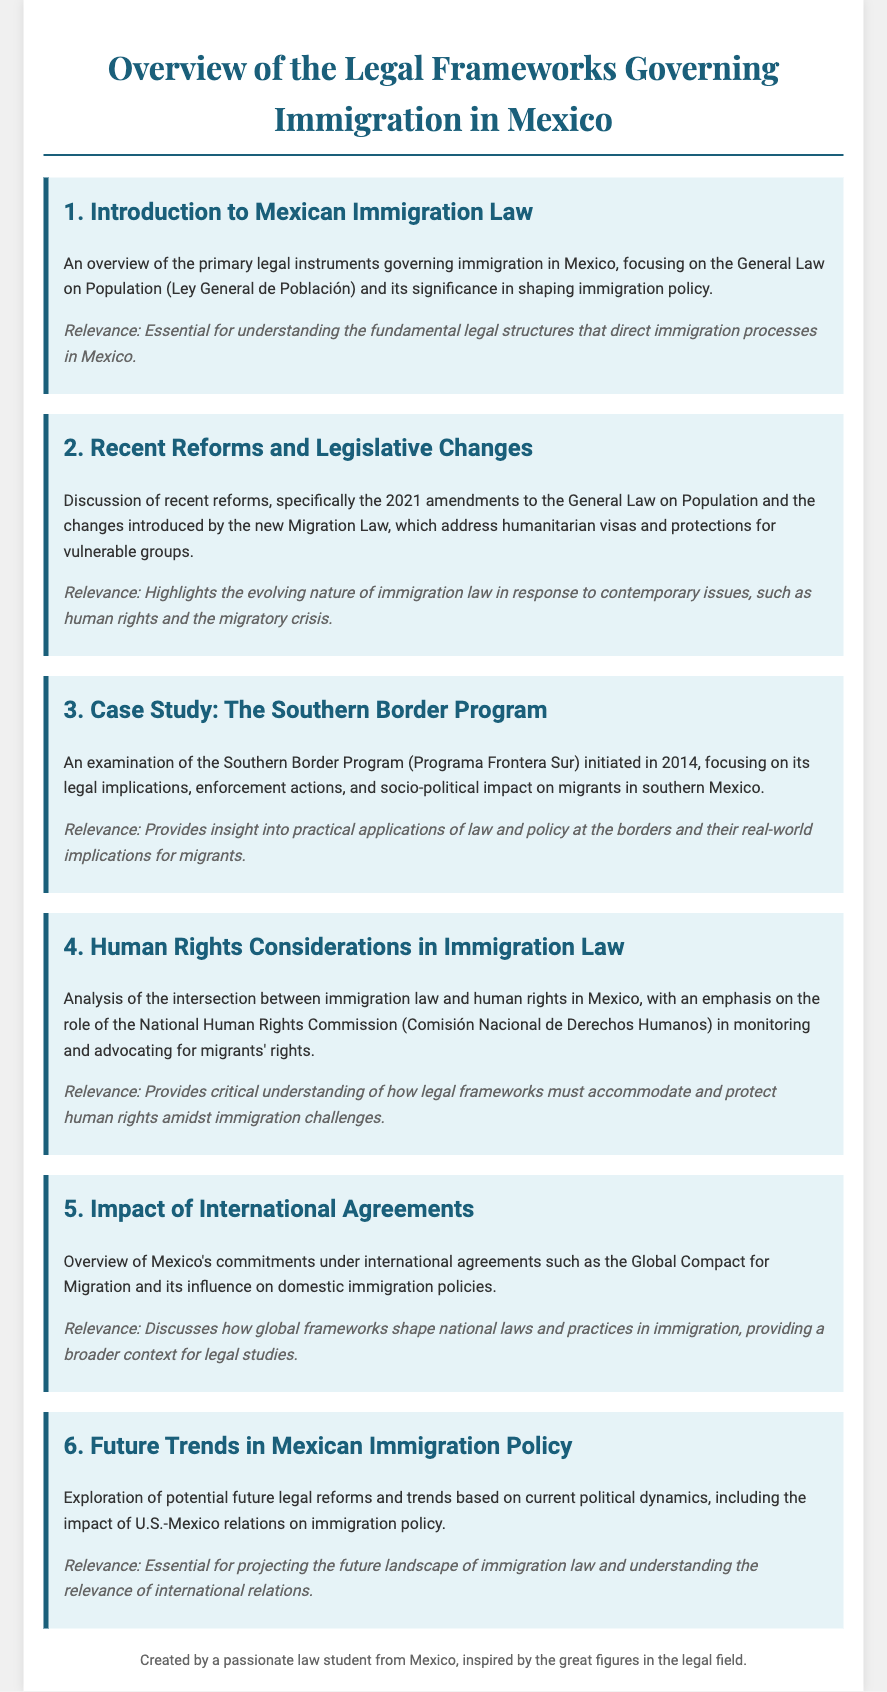What is the title of the document? The title is specified at the beginning of the document and indicates the main focus of the content.
Answer: Overview of the Legal Frameworks Governing Immigration in Mexico What year were amendments made to the General Law on Population? The amendments to the General Law on Population are specifically mentioned in the discussion of recent reforms.
Answer: 2021 What program is examined in the case study section? The case study section explicitly names the program being analyzed and its initiation year.
Answer: Southern Border Program Which commission is mentioned regarding human rights? The document references a specific commission that deals with human rights monitoring in Mexico.
Answer: National Human Rights Commission What is an example of an international agreement mentioned? The document provides an overview of Mexico's commitments under a particular global agreement impacting immigration policies.
Answer: Global Compact for Migration What future aspect is explored in the last agenda item? The last agenda item discusses potential legal reforms based on changing political dynamics.
Answer: Future trends in Mexican immigration policy 